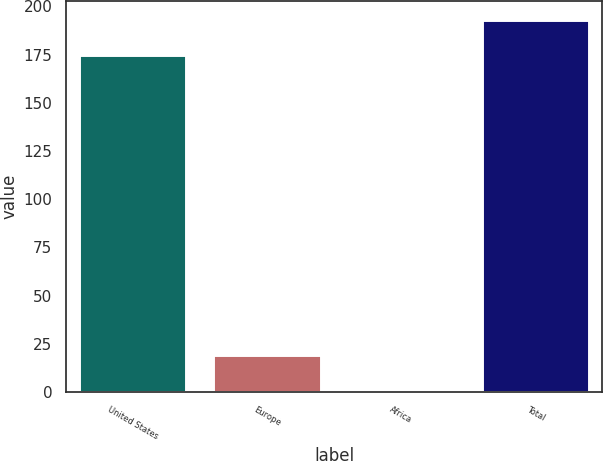Convert chart. <chart><loc_0><loc_0><loc_500><loc_500><bar_chart><fcel>United States<fcel>Europe<fcel>Africa<fcel>Total<nl><fcel>175<fcel>19.2<fcel>1<fcel>193.2<nl></chart> 